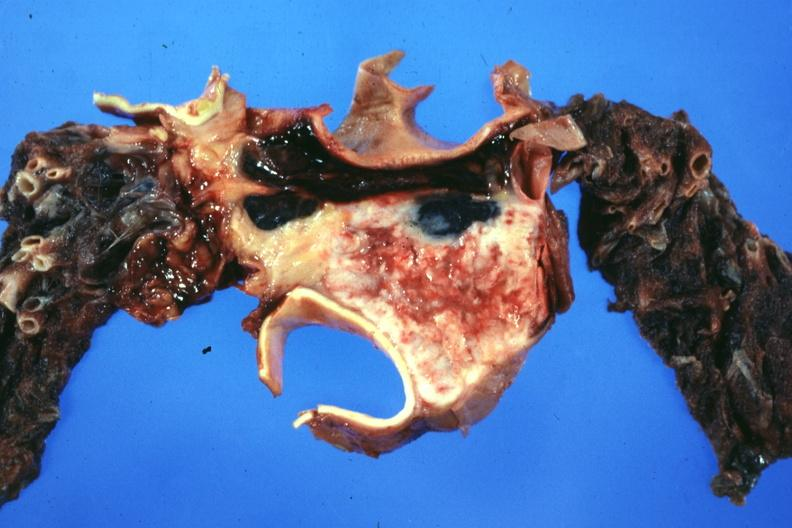what is present?
Answer the question using a single word or phrase. Hematologic 